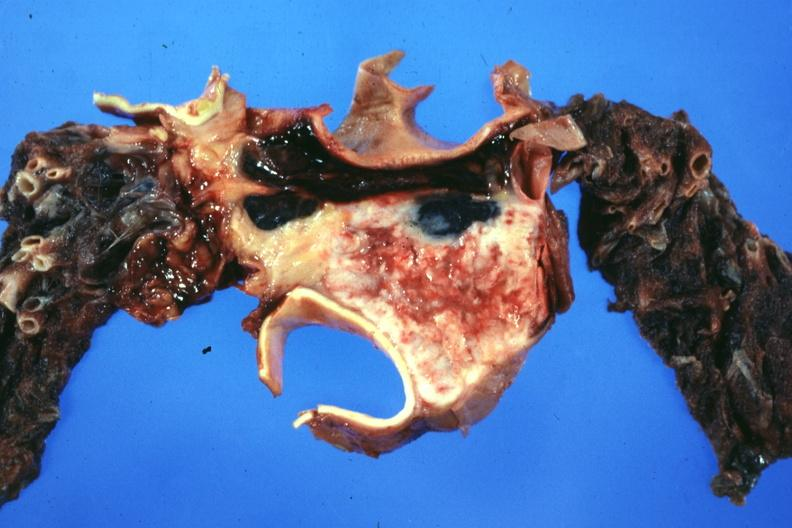what is present?
Answer the question using a single word or phrase. Hematologic 